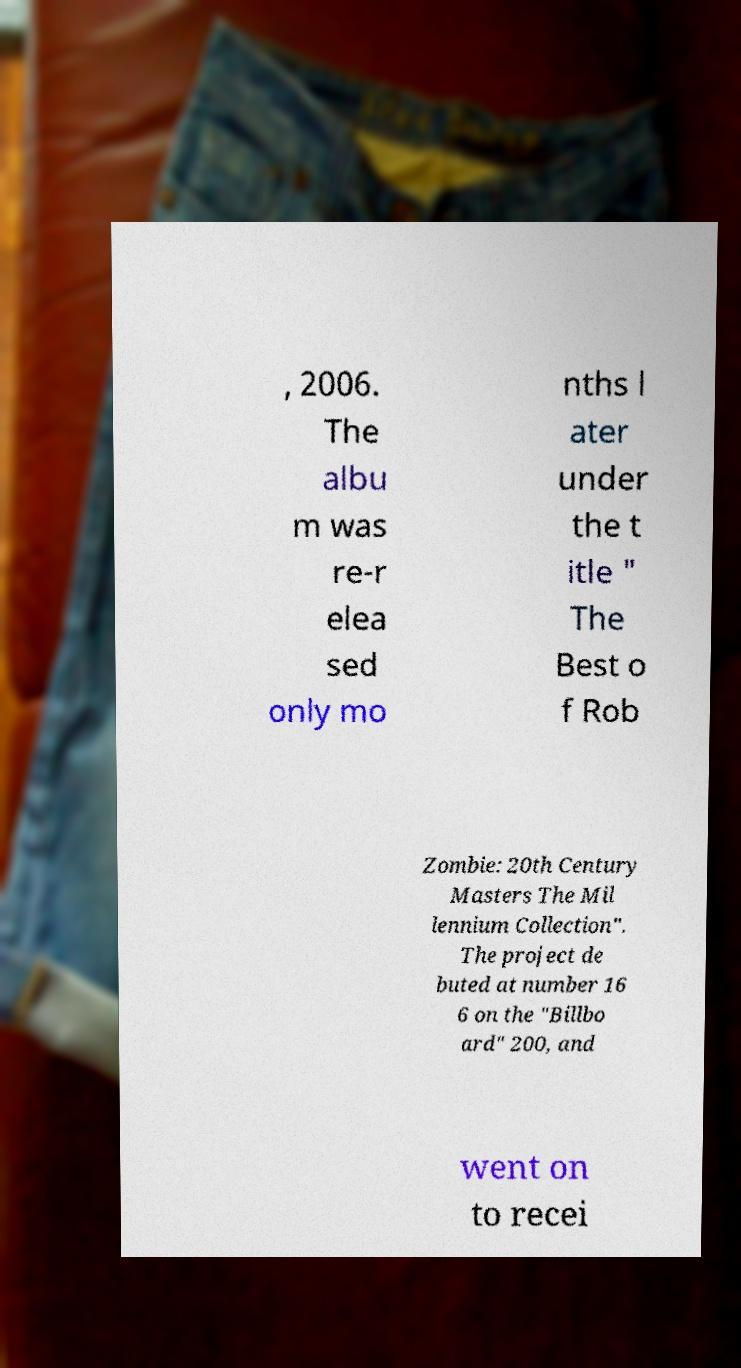Can you read and provide the text displayed in the image?This photo seems to have some interesting text. Can you extract and type it out for me? , 2006. The albu m was re-r elea sed only mo nths l ater under the t itle " The Best o f Rob Zombie: 20th Century Masters The Mil lennium Collection". The project de buted at number 16 6 on the "Billbo ard" 200, and went on to recei 